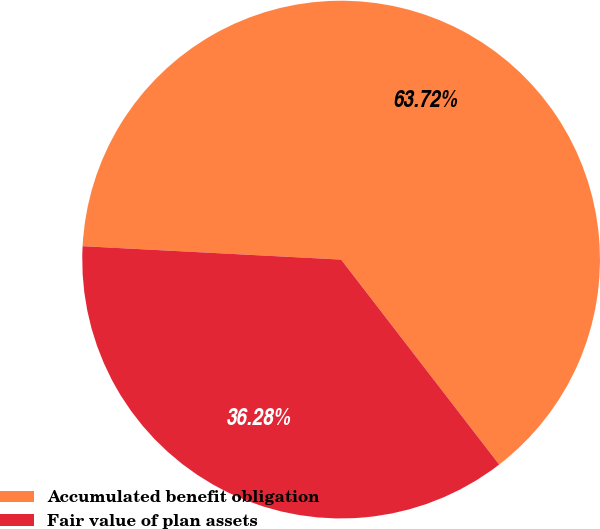<chart> <loc_0><loc_0><loc_500><loc_500><pie_chart><fcel>Accumulated benefit obligation<fcel>Fair value of plan assets<nl><fcel>63.72%<fcel>36.28%<nl></chart> 